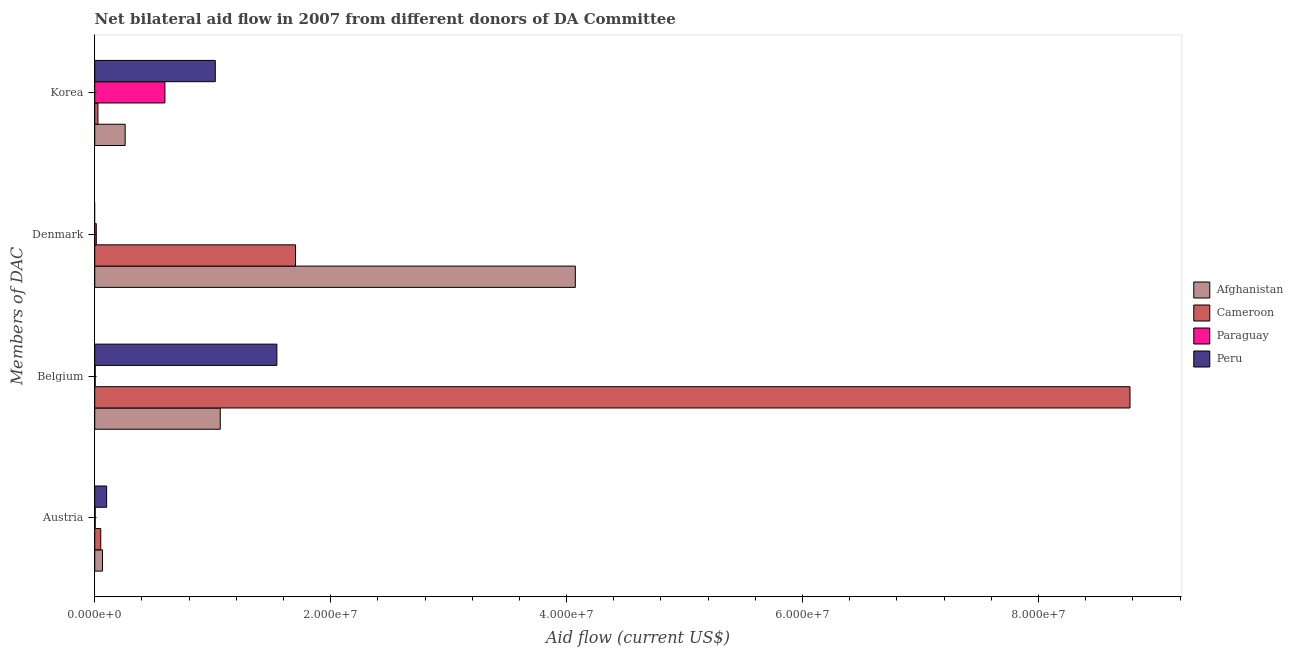Are the number of bars per tick equal to the number of legend labels?
Keep it short and to the point. No. Are the number of bars on each tick of the Y-axis equal?
Make the answer very short. No. How many bars are there on the 2nd tick from the top?
Your response must be concise. 3. How many bars are there on the 4th tick from the bottom?
Give a very brief answer. 4. What is the amount of aid given by denmark in Afghanistan?
Provide a succinct answer. 4.07e+07. Across all countries, what is the maximum amount of aid given by belgium?
Ensure brevity in your answer.  8.78e+07. Across all countries, what is the minimum amount of aid given by austria?
Your answer should be very brief. 4.00e+04. In which country was the amount of aid given by austria maximum?
Offer a terse response. Peru. What is the total amount of aid given by austria in the graph?
Give a very brief answer. 2.22e+06. What is the difference between the amount of aid given by belgium in Cameroon and that in Peru?
Provide a short and direct response. 7.23e+07. What is the difference between the amount of aid given by denmark in Peru and the amount of aid given by korea in Afghanistan?
Make the answer very short. -2.58e+06. What is the average amount of aid given by korea per country?
Your answer should be compact. 4.76e+06. What is the ratio of the amount of aid given by korea in Afghanistan to that in Peru?
Offer a very short reply. 0.25. What is the difference between the highest and the second highest amount of aid given by belgium?
Give a very brief answer. 7.23e+07. What is the difference between the highest and the lowest amount of aid given by korea?
Provide a short and direct response. 9.95e+06. How many bars are there?
Your answer should be very brief. 15. Are the values on the major ticks of X-axis written in scientific E-notation?
Your response must be concise. Yes. Does the graph contain grids?
Provide a short and direct response. No. How are the legend labels stacked?
Provide a succinct answer. Vertical. What is the title of the graph?
Make the answer very short. Net bilateral aid flow in 2007 from different donors of DA Committee. What is the label or title of the Y-axis?
Your response must be concise. Members of DAC. What is the Aid flow (current US$) of Afghanistan in Austria?
Give a very brief answer. 6.60e+05. What is the Aid flow (current US$) in Cameroon in Austria?
Your answer should be compact. 5.10e+05. What is the Aid flow (current US$) in Paraguay in Austria?
Provide a succinct answer. 4.00e+04. What is the Aid flow (current US$) of Peru in Austria?
Provide a succinct answer. 1.01e+06. What is the Aid flow (current US$) in Afghanistan in Belgium?
Make the answer very short. 1.06e+07. What is the Aid flow (current US$) of Cameroon in Belgium?
Make the answer very short. 8.78e+07. What is the Aid flow (current US$) of Peru in Belgium?
Offer a terse response. 1.54e+07. What is the Aid flow (current US$) in Afghanistan in Denmark?
Provide a succinct answer. 4.07e+07. What is the Aid flow (current US$) in Cameroon in Denmark?
Give a very brief answer. 1.70e+07. What is the Aid flow (current US$) of Peru in Denmark?
Keep it short and to the point. 0. What is the Aid flow (current US$) of Afghanistan in Korea?
Make the answer very short. 2.58e+06. What is the Aid flow (current US$) of Cameroon in Korea?
Provide a short and direct response. 2.70e+05. What is the Aid flow (current US$) in Paraguay in Korea?
Your response must be concise. 5.95e+06. What is the Aid flow (current US$) of Peru in Korea?
Ensure brevity in your answer.  1.02e+07. Across all Members of DAC, what is the maximum Aid flow (current US$) in Afghanistan?
Ensure brevity in your answer.  4.07e+07. Across all Members of DAC, what is the maximum Aid flow (current US$) in Cameroon?
Your answer should be compact. 8.78e+07. Across all Members of DAC, what is the maximum Aid flow (current US$) of Paraguay?
Your answer should be very brief. 5.95e+06. Across all Members of DAC, what is the maximum Aid flow (current US$) of Peru?
Offer a terse response. 1.54e+07. Across all Members of DAC, what is the minimum Aid flow (current US$) of Cameroon?
Ensure brevity in your answer.  2.70e+05. Across all Members of DAC, what is the minimum Aid flow (current US$) of Paraguay?
Your answer should be very brief. 4.00e+04. Across all Members of DAC, what is the minimum Aid flow (current US$) in Peru?
Your answer should be very brief. 0. What is the total Aid flow (current US$) in Afghanistan in the graph?
Ensure brevity in your answer.  5.46e+07. What is the total Aid flow (current US$) of Cameroon in the graph?
Offer a terse response. 1.06e+08. What is the total Aid flow (current US$) of Paraguay in the graph?
Your answer should be very brief. 6.16e+06. What is the total Aid flow (current US$) in Peru in the graph?
Ensure brevity in your answer.  2.67e+07. What is the difference between the Aid flow (current US$) in Afghanistan in Austria and that in Belgium?
Offer a very short reply. -9.98e+06. What is the difference between the Aid flow (current US$) in Cameroon in Austria and that in Belgium?
Make the answer very short. -8.72e+07. What is the difference between the Aid flow (current US$) in Peru in Austria and that in Belgium?
Make the answer very short. -1.44e+07. What is the difference between the Aid flow (current US$) of Afghanistan in Austria and that in Denmark?
Provide a short and direct response. -4.01e+07. What is the difference between the Aid flow (current US$) in Cameroon in Austria and that in Denmark?
Offer a very short reply. -1.65e+07. What is the difference between the Aid flow (current US$) of Paraguay in Austria and that in Denmark?
Offer a very short reply. -9.00e+04. What is the difference between the Aid flow (current US$) of Afghanistan in Austria and that in Korea?
Offer a terse response. -1.92e+06. What is the difference between the Aid flow (current US$) of Paraguay in Austria and that in Korea?
Your answer should be very brief. -5.91e+06. What is the difference between the Aid flow (current US$) in Peru in Austria and that in Korea?
Your answer should be very brief. -9.21e+06. What is the difference between the Aid flow (current US$) of Afghanistan in Belgium and that in Denmark?
Your answer should be compact. -3.01e+07. What is the difference between the Aid flow (current US$) of Cameroon in Belgium and that in Denmark?
Give a very brief answer. 7.07e+07. What is the difference between the Aid flow (current US$) of Paraguay in Belgium and that in Denmark?
Your response must be concise. -9.00e+04. What is the difference between the Aid flow (current US$) in Afghanistan in Belgium and that in Korea?
Offer a very short reply. 8.06e+06. What is the difference between the Aid flow (current US$) in Cameroon in Belgium and that in Korea?
Your response must be concise. 8.75e+07. What is the difference between the Aid flow (current US$) of Paraguay in Belgium and that in Korea?
Offer a terse response. -5.91e+06. What is the difference between the Aid flow (current US$) in Peru in Belgium and that in Korea?
Provide a short and direct response. 5.22e+06. What is the difference between the Aid flow (current US$) in Afghanistan in Denmark and that in Korea?
Ensure brevity in your answer.  3.82e+07. What is the difference between the Aid flow (current US$) in Cameroon in Denmark and that in Korea?
Make the answer very short. 1.68e+07. What is the difference between the Aid flow (current US$) in Paraguay in Denmark and that in Korea?
Provide a succinct answer. -5.82e+06. What is the difference between the Aid flow (current US$) of Afghanistan in Austria and the Aid flow (current US$) of Cameroon in Belgium?
Your answer should be very brief. -8.71e+07. What is the difference between the Aid flow (current US$) in Afghanistan in Austria and the Aid flow (current US$) in Paraguay in Belgium?
Make the answer very short. 6.20e+05. What is the difference between the Aid flow (current US$) in Afghanistan in Austria and the Aid flow (current US$) in Peru in Belgium?
Offer a terse response. -1.48e+07. What is the difference between the Aid flow (current US$) in Cameroon in Austria and the Aid flow (current US$) in Peru in Belgium?
Your answer should be very brief. -1.49e+07. What is the difference between the Aid flow (current US$) of Paraguay in Austria and the Aid flow (current US$) of Peru in Belgium?
Offer a very short reply. -1.54e+07. What is the difference between the Aid flow (current US$) in Afghanistan in Austria and the Aid flow (current US$) in Cameroon in Denmark?
Ensure brevity in your answer.  -1.64e+07. What is the difference between the Aid flow (current US$) of Afghanistan in Austria and the Aid flow (current US$) of Paraguay in Denmark?
Your response must be concise. 5.30e+05. What is the difference between the Aid flow (current US$) in Afghanistan in Austria and the Aid flow (current US$) in Paraguay in Korea?
Your answer should be very brief. -5.29e+06. What is the difference between the Aid flow (current US$) of Afghanistan in Austria and the Aid flow (current US$) of Peru in Korea?
Ensure brevity in your answer.  -9.56e+06. What is the difference between the Aid flow (current US$) of Cameroon in Austria and the Aid flow (current US$) of Paraguay in Korea?
Offer a terse response. -5.44e+06. What is the difference between the Aid flow (current US$) in Cameroon in Austria and the Aid flow (current US$) in Peru in Korea?
Offer a terse response. -9.71e+06. What is the difference between the Aid flow (current US$) in Paraguay in Austria and the Aid flow (current US$) in Peru in Korea?
Your answer should be compact. -1.02e+07. What is the difference between the Aid flow (current US$) of Afghanistan in Belgium and the Aid flow (current US$) of Cameroon in Denmark?
Your answer should be compact. -6.38e+06. What is the difference between the Aid flow (current US$) of Afghanistan in Belgium and the Aid flow (current US$) of Paraguay in Denmark?
Provide a succinct answer. 1.05e+07. What is the difference between the Aid flow (current US$) of Cameroon in Belgium and the Aid flow (current US$) of Paraguay in Denmark?
Ensure brevity in your answer.  8.76e+07. What is the difference between the Aid flow (current US$) of Afghanistan in Belgium and the Aid flow (current US$) of Cameroon in Korea?
Keep it short and to the point. 1.04e+07. What is the difference between the Aid flow (current US$) in Afghanistan in Belgium and the Aid flow (current US$) in Paraguay in Korea?
Make the answer very short. 4.69e+06. What is the difference between the Aid flow (current US$) in Cameroon in Belgium and the Aid flow (current US$) in Paraguay in Korea?
Ensure brevity in your answer.  8.18e+07. What is the difference between the Aid flow (current US$) in Cameroon in Belgium and the Aid flow (current US$) in Peru in Korea?
Your answer should be compact. 7.75e+07. What is the difference between the Aid flow (current US$) in Paraguay in Belgium and the Aid flow (current US$) in Peru in Korea?
Your response must be concise. -1.02e+07. What is the difference between the Aid flow (current US$) in Afghanistan in Denmark and the Aid flow (current US$) in Cameroon in Korea?
Provide a short and direct response. 4.05e+07. What is the difference between the Aid flow (current US$) in Afghanistan in Denmark and the Aid flow (current US$) in Paraguay in Korea?
Make the answer very short. 3.48e+07. What is the difference between the Aid flow (current US$) of Afghanistan in Denmark and the Aid flow (current US$) of Peru in Korea?
Provide a short and direct response. 3.05e+07. What is the difference between the Aid flow (current US$) of Cameroon in Denmark and the Aid flow (current US$) of Paraguay in Korea?
Provide a short and direct response. 1.11e+07. What is the difference between the Aid flow (current US$) in Cameroon in Denmark and the Aid flow (current US$) in Peru in Korea?
Give a very brief answer. 6.80e+06. What is the difference between the Aid flow (current US$) of Paraguay in Denmark and the Aid flow (current US$) of Peru in Korea?
Provide a short and direct response. -1.01e+07. What is the average Aid flow (current US$) of Afghanistan per Members of DAC?
Provide a short and direct response. 1.37e+07. What is the average Aid flow (current US$) of Cameroon per Members of DAC?
Provide a succinct answer. 2.64e+07. What is the average Aid flow (current US$) in Paraguay per Members of DAC?
Keep it short and to the point. 1.54e+06. What is the average Aid flow (current US$) of Peru per Members of DAC?
Offer a very short reply. 6.67e+06. What is the difference between the Aid flow (current US$) of Afghanistan and Aid flow (current US$) of Paraguay in Austria?
Give a very brief answer. 6.20e+05. What is the difference between the Aid flow (current US$) in Afghanistan and Aid flow (current US$) in Peru in Austria?
Provide a succinct answer. -3.50e+05. What is the difference between the Aid flow (current US$) of Cameroon and Aid flow (current US$) of Paraguay in Austria?
Offer a terse response. 4.70e+05. What is the difference between the Aid flow (current US$) of Cameroon and Aid flow (current US$) of Peru in Austria?
Provide a succinct answer. -5.00e+05. What is the difference between the Aid flow (current US$) in Paraguay and Aid flow (current US$) in Peru in Austria?
Give a very brief answer. -9.70e+05. What is the difference between the Aid flow (current US$) in Afghanistan and Aid flow (current US$) in Cameroon in Belgium?
Provide a succinct answer. -7.71e+07. What is the difference between the Aid flow (current US$) of Afghanistan and Aid flow (current US$) of Paraguay in Belgium?
Offer a terse response. 1.06e+07. What is the difference between the Aid flow (current US$) in Afghanistan and Aid flow (current US$) in Peru in Belgium?
Offer a terse response. -4.80e+06. What is the difference between the Aid flow (current US$) in Cameroon and Aid flow (current US$) in Paraguay in Belgium?
Ensure brevity in your answer.  8.77e+07. What is the difference between the Aid flow (current US$) in Cameroon and Aid flow (current US$) in Peru in Belgium?
Your response must be concise. 7.23e+07. What is the difference between the Aid flow (current US$) of Paraguay and Aid flow (current US$) of Peru in Belgium?
Provide a short and direct response. -1.54e+07. What is the difference between the Aid flow (current US$) in Afghanistan and Aid flow (current US$) in Cameroon in Denmark?
Give a very brief answer. 2.37e+07. What is the difference between the Aid flow (current US$) of Afghanistan and Aid flow (current US$) of Paraguay in Denmark?
Provide a short and direct response. 4.06e+07. What is the difference between the Aid flow (current US$) in Cameroon and Aid flow (current US$) in Paraguay in Denmark?
Give a very brief answer. 1.69e+07. What is the difference between the Aid flow (current US$) of Afghanistan and Aid flow (current US$) of Cameroon in Korea?
Your answer should be very brief. 2.31e+06. What is the difference between the Aid flow (current US$) of Afghanistan and Aid flow (current US$) of Paraguay in Korea?
Provide a short and direct response. -3.37e+06. What is the difference between the Aid flow (current US$) in Afghanistan and Aid flow (current US$) in Peru in Korea?
Your response must be concise. -7.64e+06. What is the difference between the Aid flow (current US$) of Cameroon and Aid flow (current US$) of Paraguay in Korea?
Your answer should be compact. -5.68e+06. What is the difference between the Aid flow (current US$) of Cameroon and Aid flow (current US$) of Peru in Korea?
Provide a succinct answer. -9.95e+06. What is the difference between the Aid flow (current US$) in Paraguay and Aid flow (current US$) in Peru in Korea?
Ensure brevity in your answer.  -4.27e+06. What is the ratio of the Aid flow (current US$) in Afghanistan in Austria to that in Belgium?
Your answer should be compact. 0.06. What is the ratio of the Aid flow (current US$) in Cameroon in Austria to that in Belgium?
Offer a terse response. 0.01. What is the ratio of the Aid flow (current US$) of Paraguay in Austria to that in Belgium?
Provide a short and direct response. 1. What is the ratio of the Aid flow (current US$) of Peru in Austria to that in Belgium?
Your answer should be very brief. 0.07. What is the ratio of the Aid flow (current US$) in Afghanistan in Austria to that in Denmark?
Give a very brief answer. 0.02. What is the ratio of the Aid flow (current US$) in Cameroon in Austria to that in Denmark?
Offer a terse response. 0.03. What is the ratio of the Aid flow (current US$) in Paraguay in Austria to that in Denmark?
Offer a very short reply. 0.31. What is the ratio of the Aid flow (current US$) in Afghanistan in Austria to that in Korea?
Keep it short and to the point. 0.26. What is the ratio of the Aid flow (current US$) in Cameroon in Austria to that in Korea?
Your answer should be compact. 1.89. What is the ratio of the Aid flow (current US$) of Paraguay in Austria to that in Korea?
Provide a succinct answer. 0.01. What is the ratio of the Aid flow (current US$) in Peru in Austria to that in Korea?
Make the answer very short. 0.1. What is the ratio of the Aid flow (current US$) in Afghanistan in Belgium to that in Denmark?
Your response must be concise. 0.26. What is the ratio of the Aid flow (current US$) of Cameroon in Belgium to that in Denmark?
Your answer should be compact. 5.16. What is the ratio of the Aid flow (current US$) of Paraguay in Belgium to that in Denmark?
Provide a succinct answer. 0.31. What is the ratio of the Aid flow (current US$) of Afghanistan in Belgium to that in Korea?
Your response must be concise. 4.12. What is the ratio of the Aid flow (current US$) of Cameroon in Belgium to that in Korea?
Provide a short and direct response. 325.04. What is the ratio of the Aid flow (current US$) in Paraguay in Belgium to that in Korea?
Your response must be concise. 0.01. What is the ratio of the Aid flow (current US$) in Peru in Belgium to that in Korea?
Give a very brief answer. 1.51. What is the ratio of the Aid flow (current US$) of Afghanistan in Denmark to that in Korea?
Keep it short and to the point. 15.79. What is the ratio of the Aid flow (current US$) of Cameroon in Denmark to that in Korea?
Offer a very short reply. 63.04. What is the ratio of the Aid flow (current US$) in Paraguay in Denmark to that in Korea?
Provide a short and direct response. 0.02. What is the difference between the highest and the second highest Aid flow (current US$) in Afghanistan?
Provide a short and direct response. 3.01e+07. What is the difference between the highest and the second highest Aid flow (current US$) in Cameroon?
Keep it short and to the point. 7.07e+07. What is the difference between the highest and the second highest Aid flow (current US$) of Paraguay?
Provide a short and direct response. 5.82e+06. What is the difference between the highest and the second highest Aid flow (current US$) of Peru?
Provide a short and direct response. 5.22e+06. What is the difference between the highest and the lowest Aid flow (current US$) in Afghanistan?
Make the answer very short. 4.01e+07. What is the difference between the highest and the lowest Aid flow (current US$) of Cameroon?
Your answer should be compact. 8.75e+07. What is the difference between the highest and the lowest Aid flow (current US$) in Paraguay?
Give a very brief answer. 5.91e+06. What is the difference between the highest and the lowest Aid flow (current US$) in Peru?
Your response must be concise. 1.54e+07. 